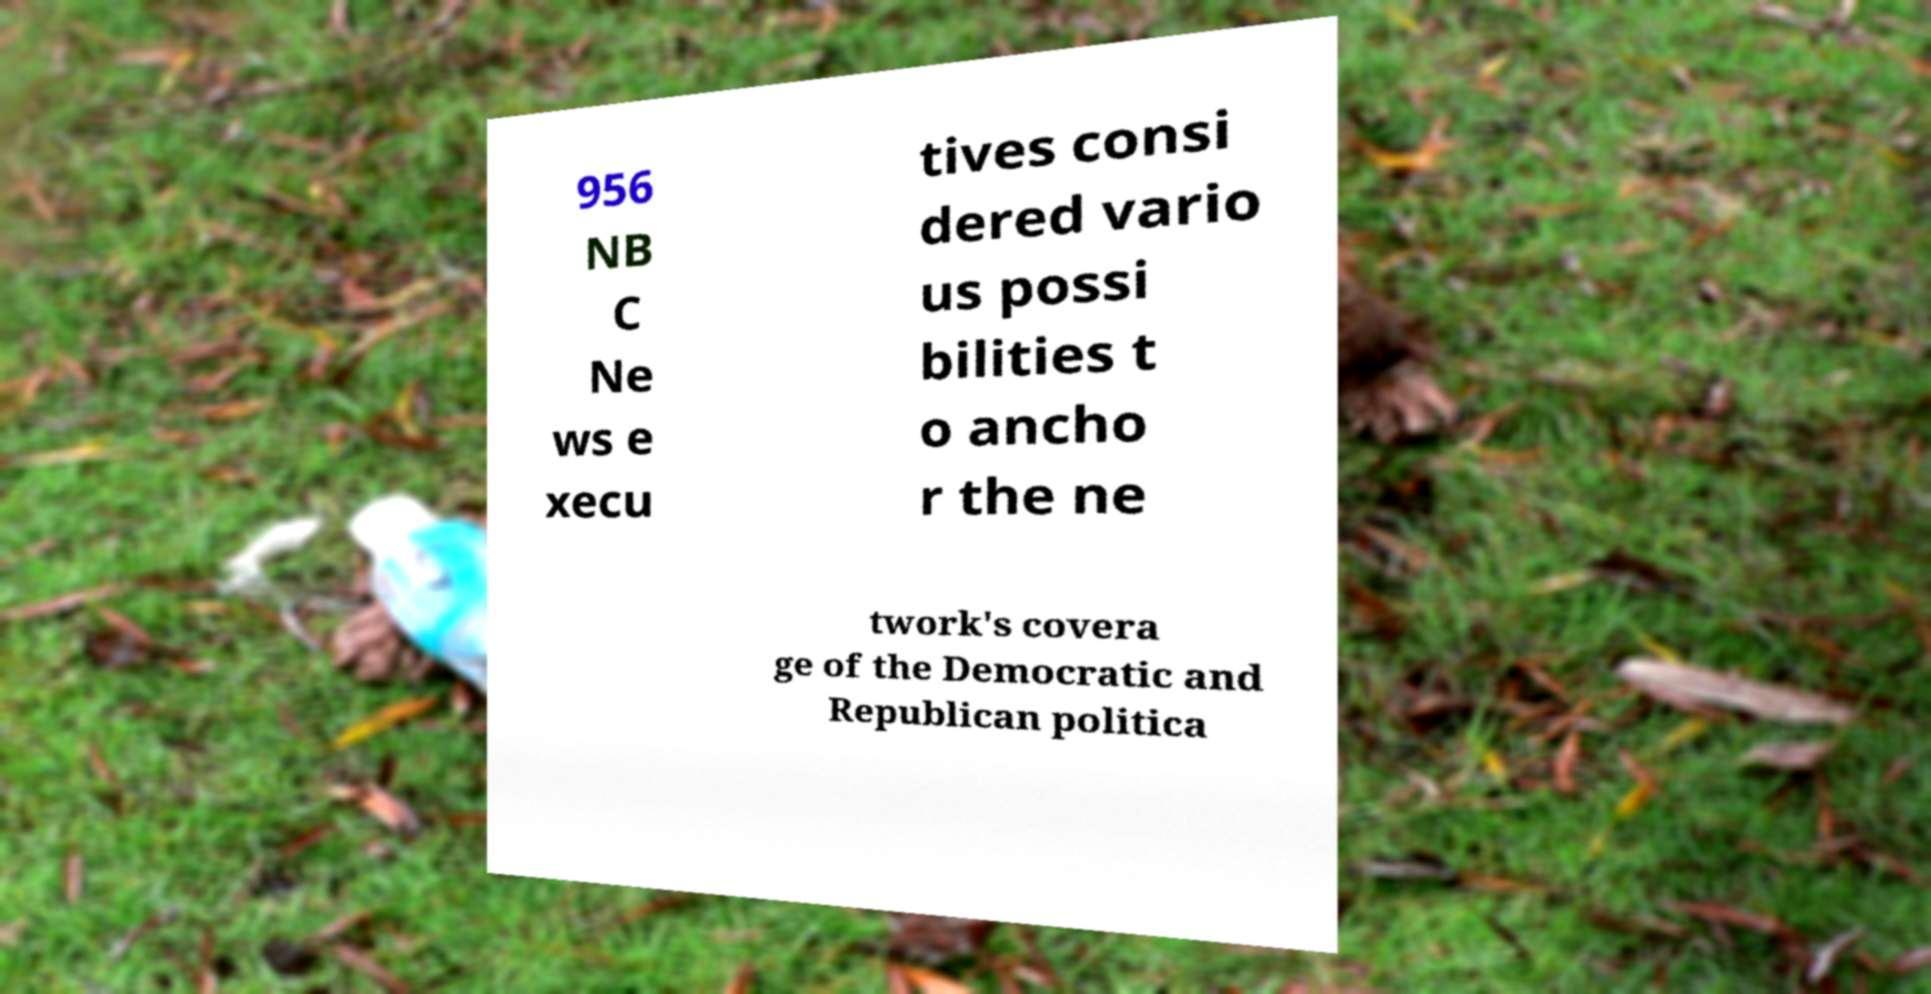There's text embedded in this image that I need extracted. Can you transcribe it verbatim? 956 NB C Ne ws e xecu tives consi dered vario us possi bilities t o ancho r the ne twork's covera ge of the Democratic and Republican politica 